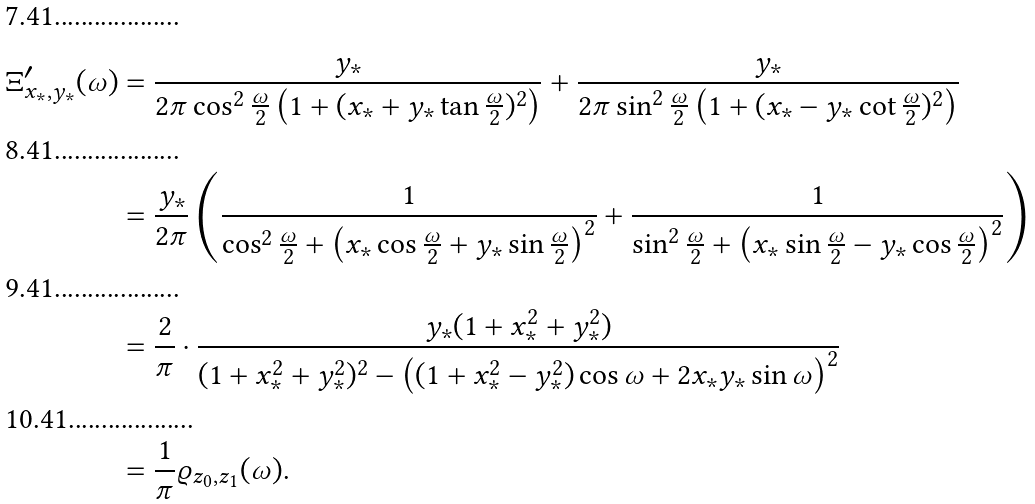Convert formula to latex. <formula><loc_0><loc_0><loc_500><loc_500>\Xi _ { x _ { * } , y _ { * } } ^ { \prime } ( \omega ) & = \frac { y _ { * } } { 2 \pi \cos ^ { 2 } \frac { \omega } { 2 } \left ( 1 + ( x _ { * } + y _ { * } \tan \frac { \omega } { 2 } ) ^ { 2 } \right ) } + \frac { y _ { * } } { 2 \pi \sin ^ { 2 } \frac { \omega } { 2 } \left ( 1 + ( x _ { * } - y _ { * } \cot \frac { \omega } { 2 } ) ^ { 2 } \right ) } \\ & = \frac { y _ { * } } { 2 \pi } \left ( \frac { 1 } { \cos ^ { 2 } \frac { \omega } { 2 } + \left ( x _ { * } \cos \frac { \omega } { 2 } + y _ { * } \sin \frac { \omega } { 2 } \right ) ^ { 2 } } + \frac { 1 } { \sin ^ { 2 } \frac { \omega } { 2 } + \left ( x _ { * } \sin \frac { \omega } { 2 } - y _ { * } \cos \frac { \omega } { 2 } \right ) ^ { 2 } } \right ) \\ & = \frac { 2 } { \pi } \cdot \frac { y _ { * } ( 1 + x _ { * } ^ { 2 } + y _ { * } ^ { 2 } ) } { ( 1 + x _ { * } ^ { 2 } + y _ { * } ^ { 2 } ) ^ { 2 } - \left ( ( 1 + x _ { * } ^ { 2 } - y _ { * } ^ { 2 } ) \cos \omega + 2 x _ { * } y _ { * } \sin \omega \right ) ^ { 2 } } \\ & = \frac { 1 } { \pi } \varrho _ { z _ { 0 } , z _ { 1 } } ( \omega ) .</formula> 